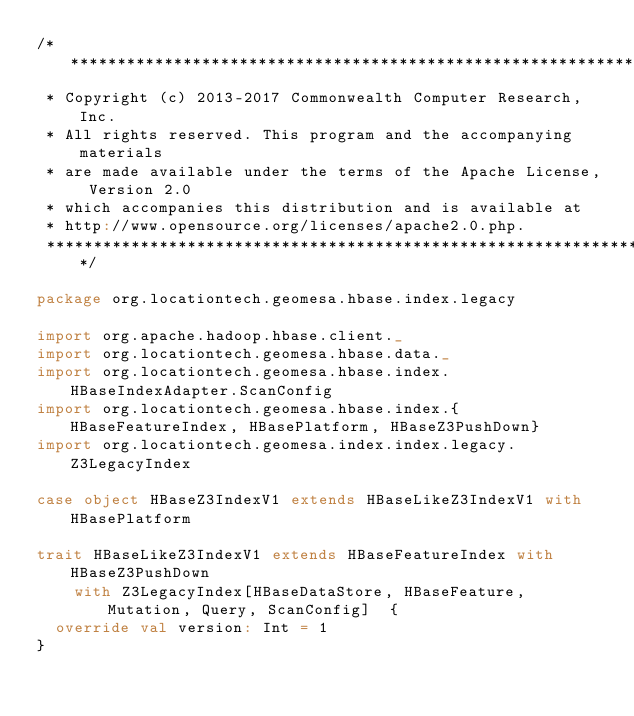Convert code to text. <code><loc_0><loc_0><loc_500><loc_500><_Scala_>/***********************************************************************
 * Copyright (c) 2013-2017 Commonwealth Computer Research, Inc.
 * All rights reserved. This program and the accompanying materials
 * are made available under the terms of the Apache License, Version 2.0
 * which accompanies this distribution and is available at
 * http://www.opensource.org/licenses/apache2.0.php.
 ***********************************************************************/

package org.locationtech.geomesa.hbase.index.legacy

import org.apache.hadoop.hbase.client._
import org.locationtech.geomesa.hbase.data._
import org.locationtech.geomesa.hbase.index.HBaseIndexAdapter.ScanConfig
import org.locationtech.geomesa.hbase.index.{HBaseFeatureIndex, HBasePlatform, HBaseZ3PushDown}
import org.locationtech.geomesa.index.index.legacy.Z3LegacyIndex

case object HBaseZ3IndexV1 extends HBaseLikeZ3IndexV1 with HBasePlatform

trait HBaseLikeZ3IndexV1 extends HBaseFeatureIndex with HBaseZ3PushDown
    with Z3LegacyIndex[HBaseDataStore, HBaseFeature, Mutation, Query, ScanConfig]  {
  override val version: Int = 1
}
</code> 